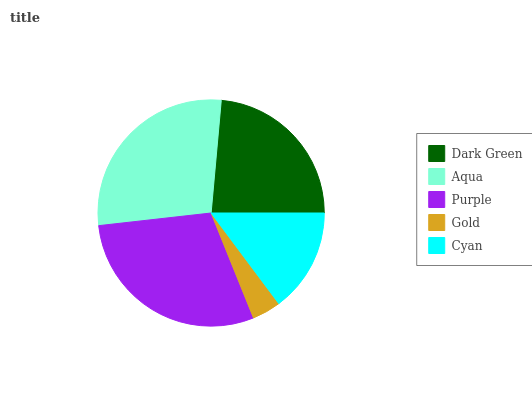Is Gold the minimum?
Answer yes or no. Yes. Is Purple the maximum?
Answer yes or no. Yes. Is Aqua the minimum?
Answer yes or no. No. Is Aqua the maximum?
Answer yes or no. No. Is Aqua greater than Dark Green?
Answer yes or no. Yes. Is Dark Green less than Aqua?
Answer yes or no. Yes. Is Dark Green greater than Aqua?
Answer yes or no. No. Is Aqua less than Dark Green?
Answer yes or no. No. Is Dark Green the high median?
Answer yes or no. Yes. Is Dark Green the low median?
Answer yes or no. Yes. Is Aqua the high median?
Answer yes or no. No. Is Aqua the low median?
Answer yes or no. No. 